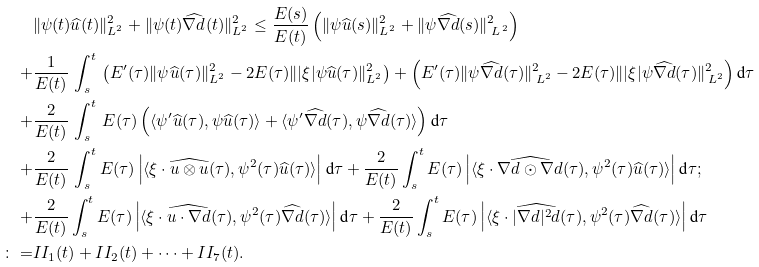Convert formula to latex. <formula><loc_0><loc_0><loc_500><loc_500>& \| \psi ( t ) \widehat { u } ( t ) \| _ { L ^ { 2 } } ^ { 2 } + \| \psi ( t ) \widehat { \nabla d } ( t ) \| _ { L ^ { 2 } } ^ { 2 } \leq \frac { E ( s ) } { E ( t ) } \left ( \| \psi \widehat { u } ( s ) \| _ { L ^ { 2 } } ^ { 2 } + \| \psi \widehat { \nabla d } ( s ) \| _ { \, L ^ { \, 2 } } ^ { 2 } \right ) \\ + & \frac { 1 } { E ( t ) } \, \int _ { s } ^ { t } \, \left ( E ^ { \prime } ( \tau ) \| \psi \widehat { u } ( \tau ) \| _ { L ^ { 2 } } ^ { 2 } - 2 E ( \tau ) \| | \xi | \psi \widehat { u } ( \tau ) \| _ { L ^ { 2 } } ^ { 2 } \right ) + \left ( E ^ { \prime } ( \tau ) \| \psi \widehat { \nabla d } ( \tau ) \| _ { \, L ^ { 2 } } ^ { 2 } - 2 E ( \tau ) \| | \xi | \psi \widehat { \nabla d } ( \tau ) \| _ { \, L ^ { 2 } } ^ { 2 } \right ) \text {d} \tau \\ + & \frac { 2 } { E ( t ) } \, \int _ { s } ^ { t } \, E ( \tau ) \left ( \langle \psi ^ { \prime } \widehat { u } ( \tau ) , \psi \widehat { u } ( \tau ) \rangle + \langle \psi ^ { \prime } \widehat { \nabla d } ( \tau ) , \psi \widehat { \nabla d } ( \tau ) \rangle \right ) \text {d} \tau \\ + & \frac { 2 } { E ( t ) } \, \int _ { s } ^ { t } E ( \tau ) \left | \langle \xi \cdot \widehat { u \otimes u } ( \tau ) , \psi ^ { 2 } ( \tau ) \widehat { u } ( \tau ) \rangle \right | \text {d} \tau + \frac { 2 } { E ( t ) } \int _ { s } ^ { t } E ( \tau ) \left | \langle \xi \cdot \widehat { \nabla d \odot \nabla d } ( \tau ) , \psi ^ { 2 } ( \tau ) \widehat { u } ( \tau ) \rangle \right | \text {d} \tau ; \\ + & \frac { 2 } { E ( t ) } \int _ { s } ^ { t } E ( \tau ) \left | \langle \xi \cdot \widehat { u \cdot \nabla d } ( \tau ) , \psi ^ { 2 } ( \tau ) \widehat { \nabla d } ( \tau ) \rangle \right | \text {d} \tau + \frac { 2 } { E ( t ) } \int _ { s } ^ { t } E ( \tau ) \left | \langle \xi \cdot \widehat { | \nabla d | ^ { 2 } d } ( \tau ) , \psi ^ { 2 } ( \tau ) \widehat { \nabla d } ( \tau ) \rangle \right | \text {d} \tau \\ \colon = & I I _ { 1 } ( t ) + I I _ { 2 } ( t ) + \cdots + I I _ { 7 } ( t ) .</formula> 